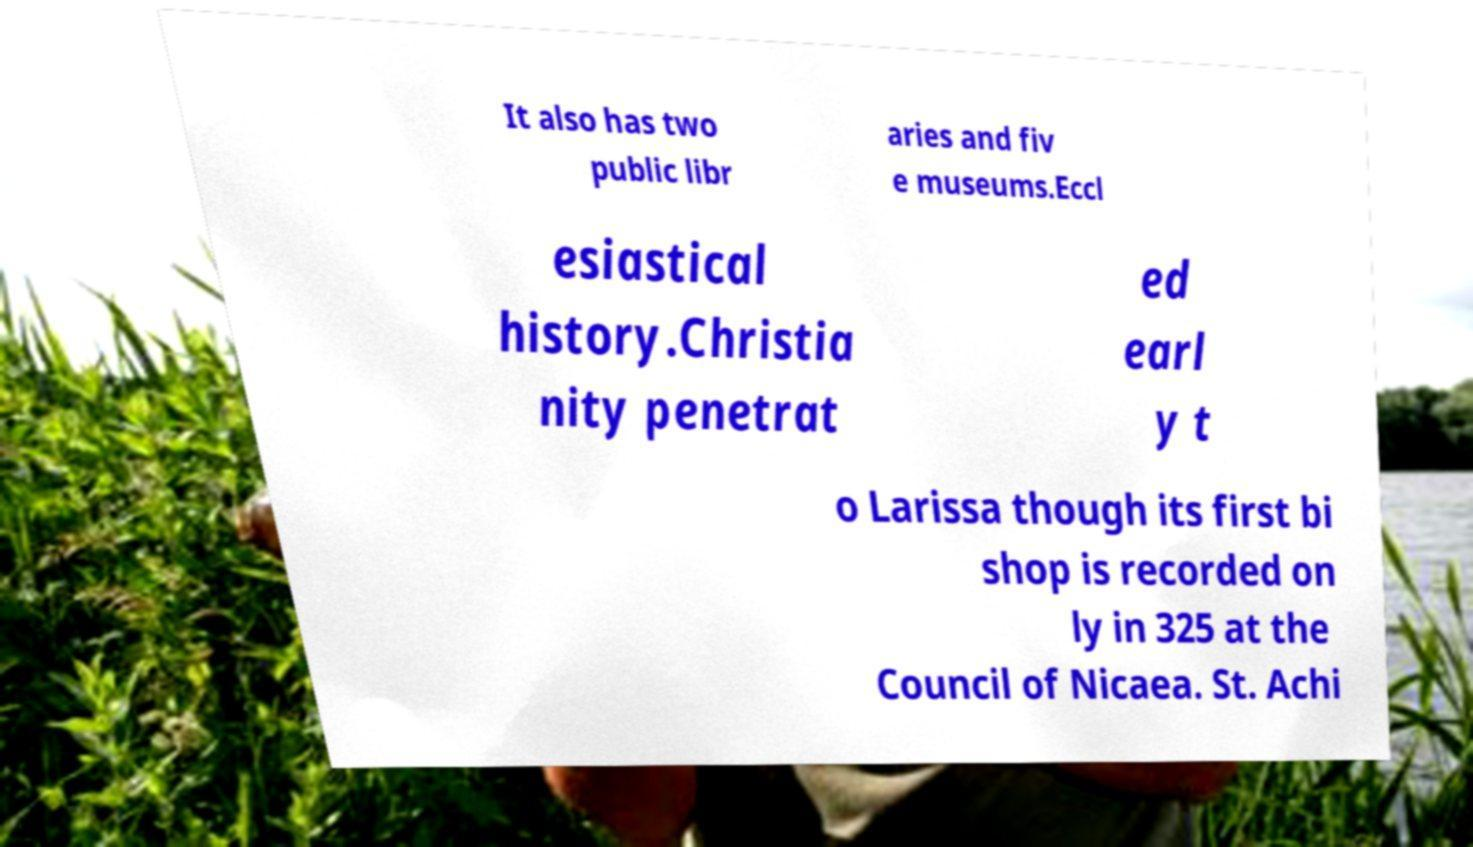Could you extract and type out the text from this image? It also has two public libr aries and fiv e museums.Eccl esiastical history.Christia nity penetrat ed earl y t o Larissa though its first bi shop is recorded on ly in 325 at the Council of Nicaea. St. Achi 